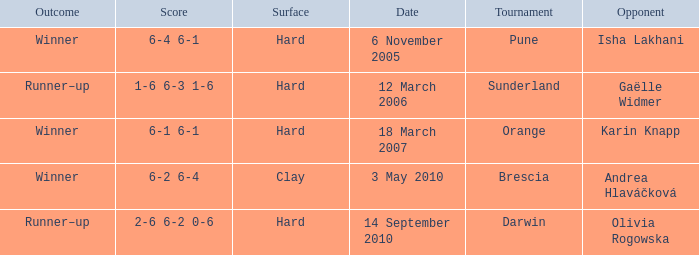What kind of surface was the tournament at Pune played on? Hard. 